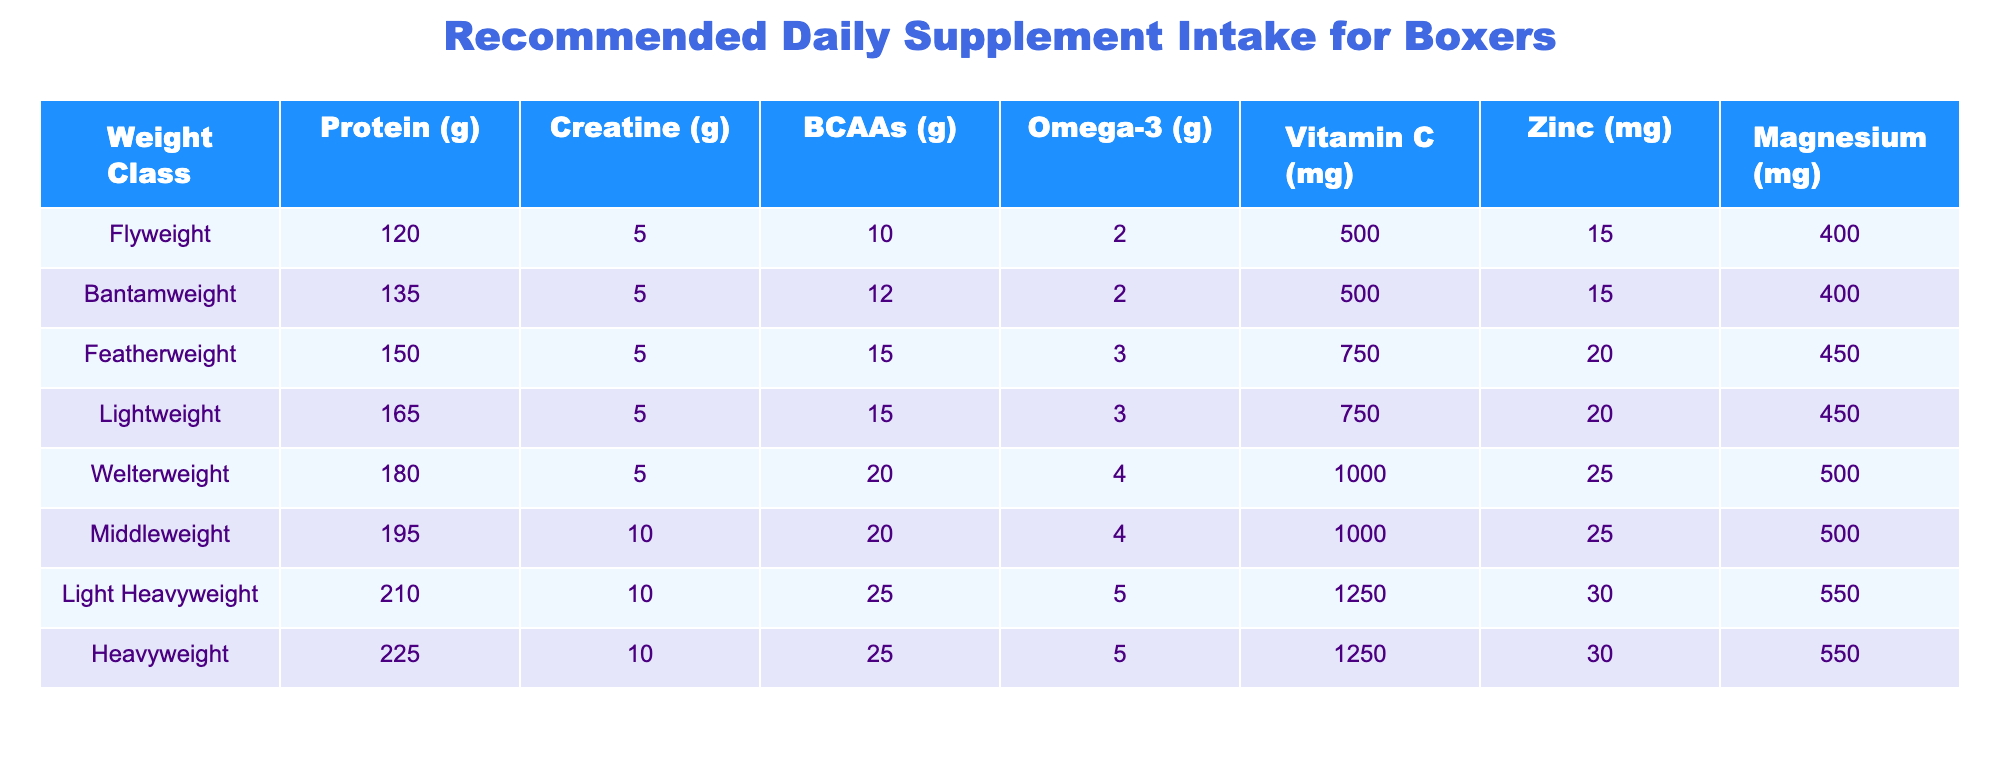What is the recommended protein intake for Featherweight boxers? The table indicates that for the Featherweight class, the recommended protein intake is 150 grams. This is specified directly in the row corresponding to the Featherweight weight class.
Answer: 150 grams How much Omega-3 should a Welterweight boxer take daily? Referring to the Welterweight row in the table, it shows that the daily intake of Omega-3 for this weight class is 4 grams.
Answer: 4 grams Which weight class has the highest Vitamin C recommendation? By examining the table, we find that the Light Heavyweight and Heavyweight classes both have a Vitamin C recommendation of 1250 mg, which is the highest among all weight classes listed.
Answer: Light Heavyweight and Heavyweight What is the sum of the recommended Zinc intake for Flyweight and Bantamweight boxers? The Zinc intake for Flyweight is 15 mg and for Bantamweight is also 15 mg. Summing these gives 15 + 15 = 30 mg.
Answer: 30 mg Is the recommended Magnesium intake the same for Middleweight and Heavyweight boxers? Looking at the table, the Magnesium intake for Middleweight is 500 mg and for Heavyweight is 550 mg. Since these values differ, the answer is no.
Answer: No How many grams of BCAAs should a Lightweight boxer take compared to a Bantamweight? From the table, a Lightweight requires 15 grams of BCAAs, while a Bantamweight requires 12 grams. The difference is 15 - 12 = 3 grams, which means the Lightweight boxer should take 3 grams more.
Answer: 3 grams more Which weight classes require a daily intake of 10 grams of Creatine? The table shows that both the Middleweight and the Light Heavyweight classes have a recommended intake of 10 grams of Creatine. Therefore, both these weight classes fall under this criterion.
Answer: Middleweight and Light Heavyweight What is the average recommended intake of protein across all weight classes? To find the average protein intake, we sum all the protein intakes: 120 + 135 + 150 + 165 + 180 + 195 + 210 + 225 = 1260 grams. There are 8 weight classes, so the average is 1260 / 8 = 157.5 grams.
Answer: 157.5 grams Do Bantamweight boxers take more Magnesium than Flyweight boxers? In the table, Bantamweight has a Magnesium intake of 400 mg while Flyweight also has 400 mg. Since they are equal, the answer is no.
Answer: No 